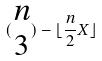Convert formula to latex. <formula><loc_0><loc_0><loc_500><loc_500>( \begin{matrix} n \\ 3 \end{matrix} ) - \lfloor \frac { n } { 2 } X \rfloor</formula> 